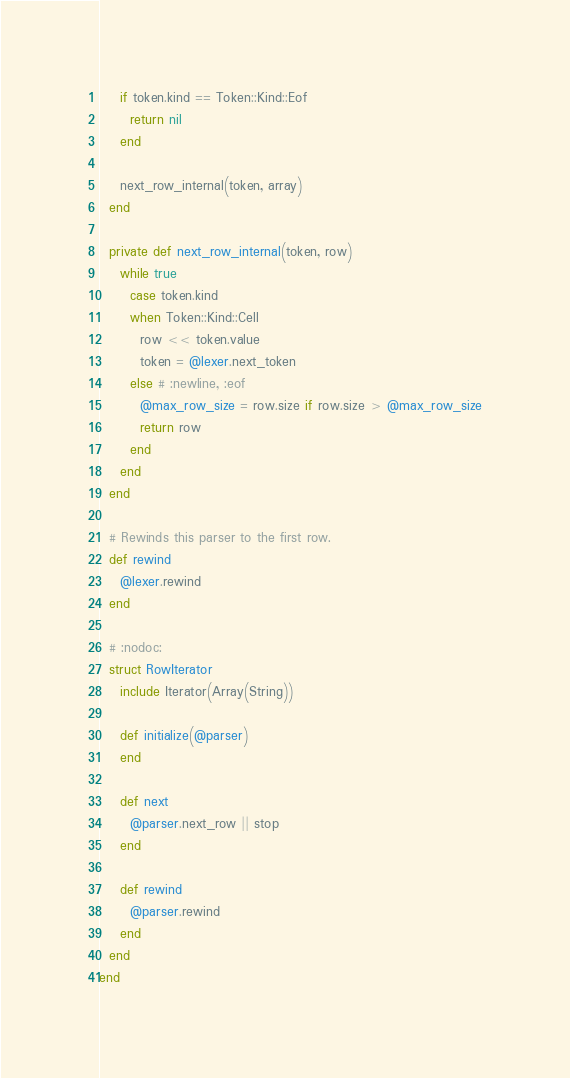Convert code to text. <code><loc_0><loc_0><loc_500><loc_500><_Crystal_>    if token.kind == Token::Kind::Eof
      return nil
    end

    next_row_internal(token, array)
  end

  private def next_row_internal(token, row)
    while true
      case token.kind
      when Token::Kind::Cell
        row << token.value
        token = @lexer.next_token
      else # :newline, :eof
        @max_row_size = row.size if row.size > @max_row_size
        return row
      end
    end
  end

  # Rewinds this parser to the first row.
  def rewind
    @lexer.rewind
  end

  # :nodoc:
  struct RowIterator
    include Iterator(Array(String))

    def initialize(@parser)
    end

    def next
      @parser.next_row || stop
    end

    def rewind
      @parser.rewind
    end
  end
end
</code> 